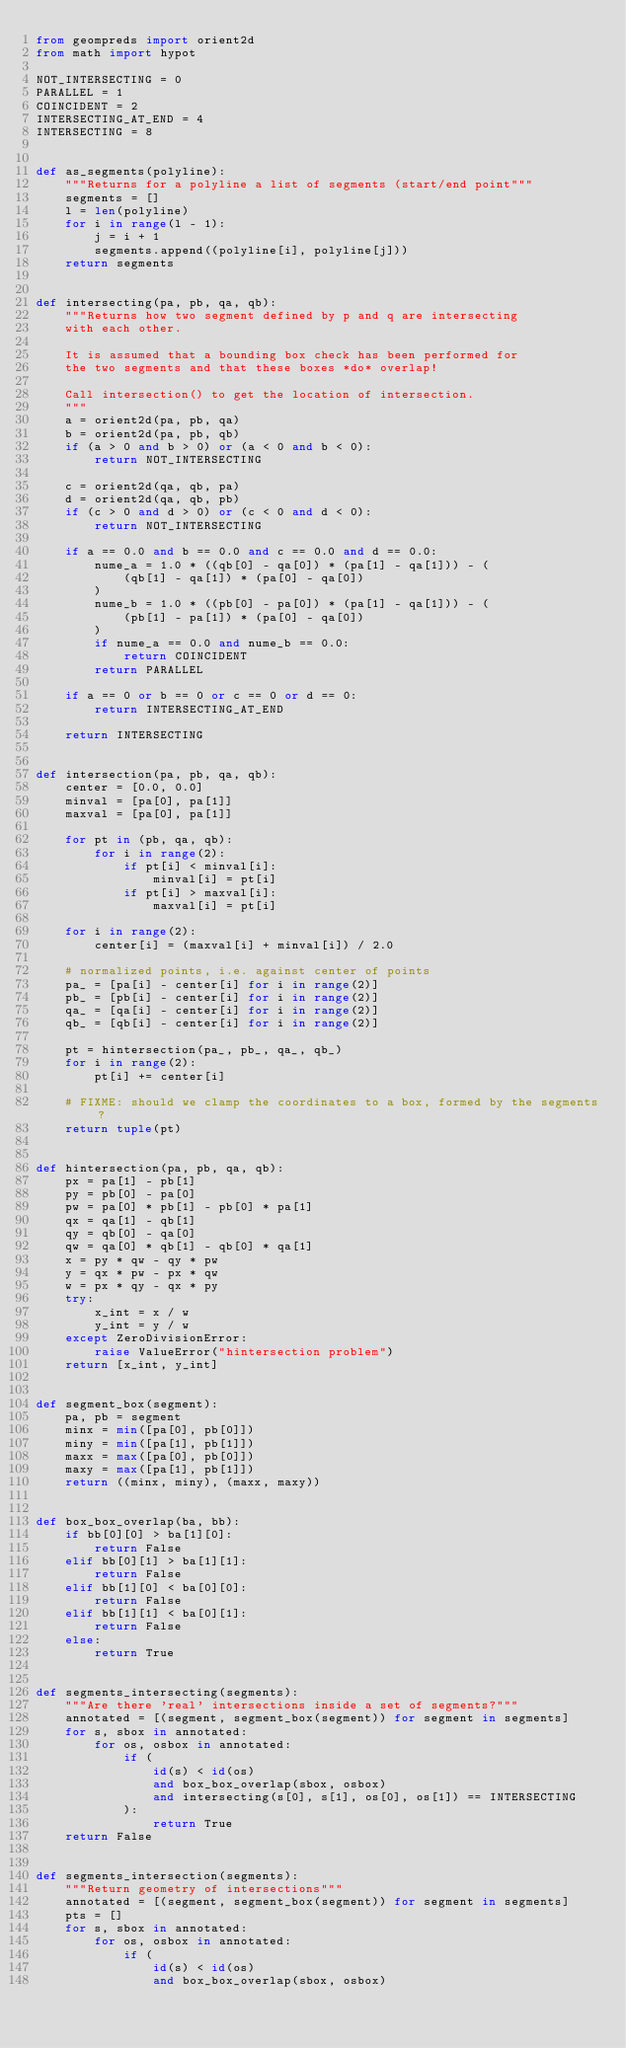<code> <loc_0><loc_0><loc_500><loc_500><_Python_>from geompreds import orient2d
from math import hypot

NOT_INTERSECTING = 0
PARALLEL = 1
COINCIDENT = 2
INTERSECTING_AT_END = 4
INTERSECTING = 8


def as_segments(polyline):
    """Returns for a polyline a list of segments (start/end point"""
    segments = []
    l = len(polyline)
    for i in range(l - 1):
        j = i + 1
        segments.append((polyline[i], polyline[j]))
    return segments


def intersecting(pa, pb, qa, qb):
    """Returns how two segment defined by p and q are intersecting
    with each other.

    It is assumed that a bounding box check has been performed for
    the two segments and that these boxes *do* overlap!

    Call intersection() to get the location of intersection.
    """
    a = orient2d(pa, pb, qa)
    b = orient2d(pa, pb, qb)
    if (a > 0 and b > 0) or (a < 0 and b < 0):
        return NOT_INTERSECTING

    c = orient2d(qa, qb, pa)
    d = orient2d(qa, qb, pb)
    if (c > 0 and d > 0) or (c < 0 and d < 0):
        return NOT_INTERSECTING

    if a == 0.0 and b == 0.0 and c == 0.0 and d == 0.0:
        nume_a = 1.0 * ((qb[0] - qa[0]) * (pa[1] - qa[1])) - (
            (qb[1] - qa[1]) * (pa[0] - qa[0])
        )
        nume_b = 1.0 * ((pb[0] - pa[0]) * (pa[1] - qa[1])) - (
            (pb[1] - pa[1]) * (pa[0] - qa[0])
        )
        if nume_a == 0.0 and nume_b == 0.0:
            return COINCIDENT
        return PARALLEL

    if a == 0 or b == 0 or c == 0 or d == 0:
        return INTERSECTING_AT_END

    return INTERSECTING


def intersection(pa, pb, qa, qb):
    center = [0.0, 0.0]
    minval = [pa[0], pa[1]]
    maxval = [pa[0], pa[1]]

    for pt in (pb, qa, qb):
        for i in range(2):
            if pt[i] < minval[i]:
                minval[i] = pt[i]
            if pt[i] > maxval[i]:
                maxval[i] = pt[i]

    for i in range(2):
        center[i] = (maxval[i] + minval[i]) / 2.0

    # normalized points, i.e. against center of points
    pa_ = [pa[i] - center[i] for i in range(2)]
    pb_ = [pb[i] - center[i] for i in range(2)]
    qa_ = [qa[i] - center[i] for i in range(2)]
    qb_ = [qb[i] - center[i] for i in range(2)]

    pt = hintersection(pa_, pb_, qa_, qb_)
    for i in range(2):
        pt[i] += center[i]

    # FIXME: should we clamp the coordinates to a box, formed by the segments?
    return tuple(pt)


def hintersection(pa, pb, qa, qb):
    px = pa[1] - pb[1]
    py = pb[0] - pa[0]
    pw = pa[0] * pb[1] - pb[0] * pa[1]
    qx = qa[1] - qb[1]
    qy = qb[0] - qa[0]
    qw = qa[0] * qb[1] - qb[0] * qa[1]
    x = py * qw - qy * pw
    y = qx * pw - px * qw
    w = px * qy - qx * py
    try:
        x_int = x / w
        y_int = y / w
    except ZeroDivisionError:
        raise ValueError("hintersection problem")
    return [x_int, y_int]


def segment_box(segment):
    pa, pb = segment
    minx = min([pa[0], pb[0]])
    miny = min([pa[1], pb[1]])
    maxx = max([pa[0], pb[0]])
    maxy = max([pa[1], pb[1]])
    return ((minx, miny), (maxx, maxy))


def box_box_overlap(ba, bb):
    if bb[0][0] > ba[1][0]:
        return False
    elif bb[0][1] > ba[1][1]:
        return False
    elif bb[1][0] < ba[0][0]:
        return False
    elif bb[1][1] < ba[0][1]:
        return False
    else:
        return True


def segments_intersecting(segments):
    """Are there 'real' intersections inside a set of segments?"""
    annotated = [(segment, segment_box(segment)) for segment in segments]
    for s, sbox in annotated:
        for os, osbox in annotated:
            if (
                id(s) < id(os)
                and box_box_overlap(sbox, osbox)
                and intersecting(s[0], s[1], os[0], os[1]) == INTERSECTING
            ):
                return True
    return False


def segments_intersection(segments):
    """Return geometry of intersections"""
    annotated = [(segment, segment_box(segment)) for segment in segments]
    pts = []
    for s, sbox in annotated:
        for os, osbox in annotated:
            if (
                id(s) < id(os)
                and box_box_overlap(sbox, osbox)</code> 